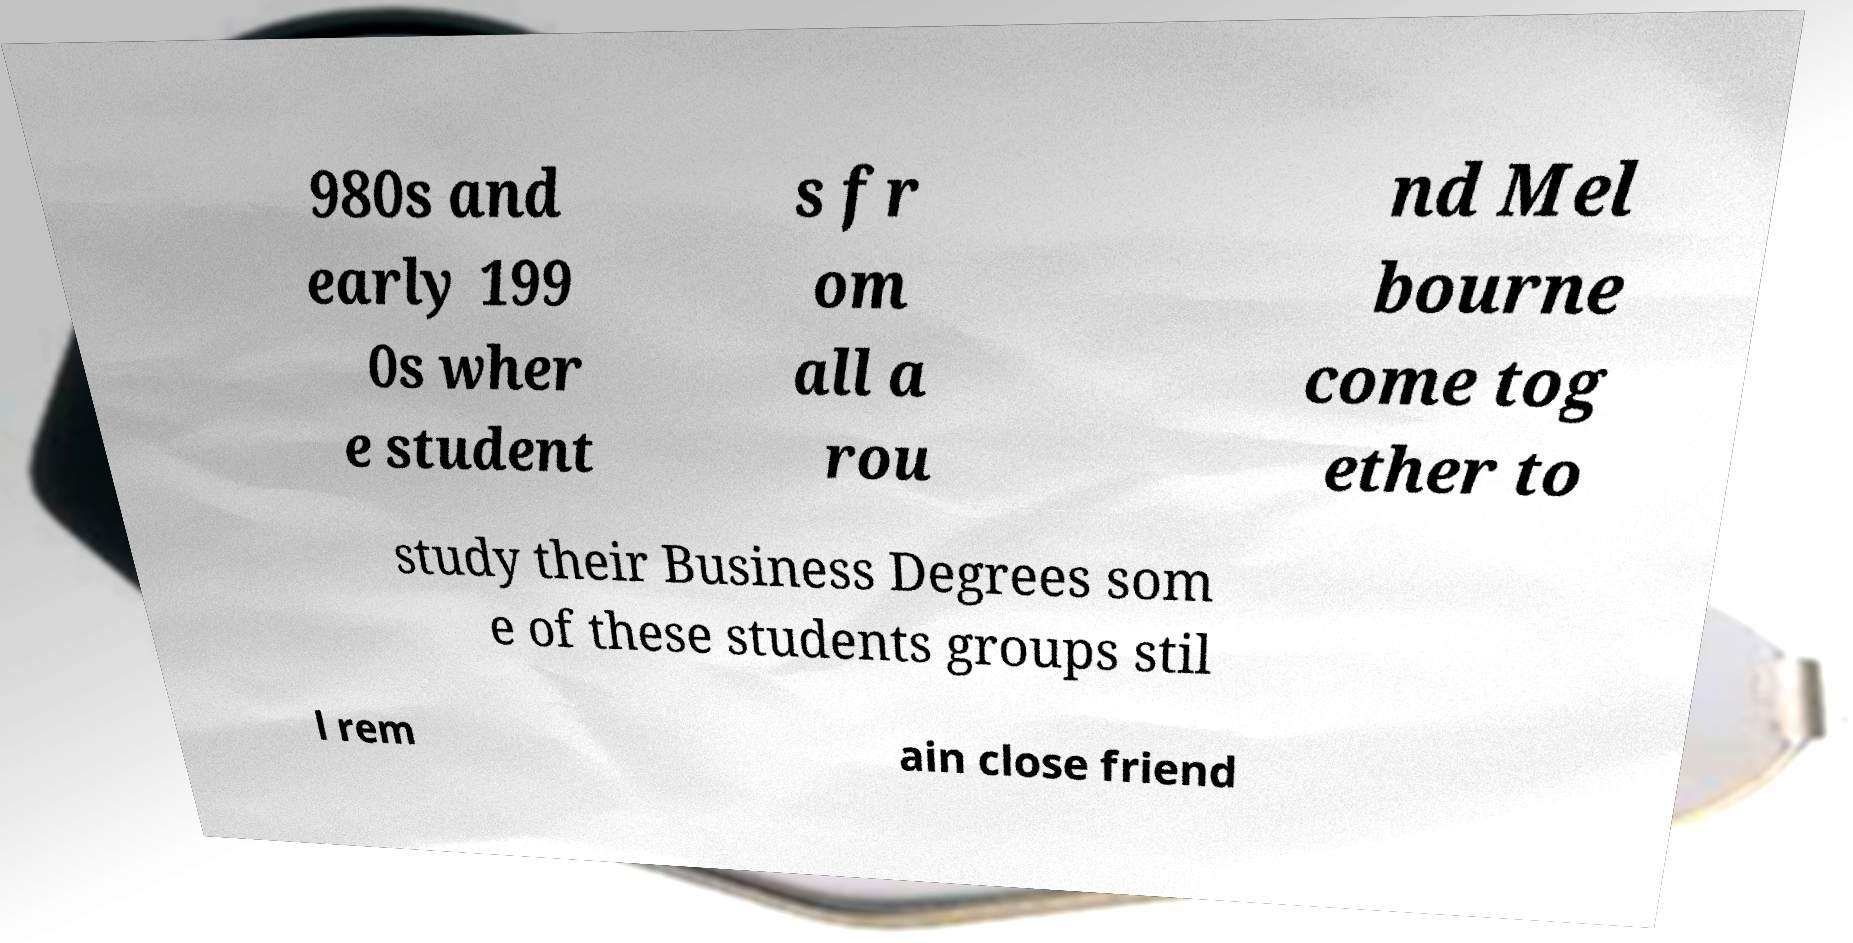Can you read and provide the text displayed in the image?This photo seems to have some interesting text. Can you extract and type it out for me? 980s and early 199 0s wher e student s fr om all a rou nd Mel bourne come tog ether to study their Business Degrees som e of these students groups stil l rem ain close friend 